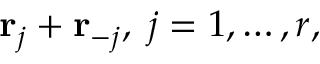Convert formula to latex. <formula><loc_0><loc_0><loc_500><loc_500>{ r } _ { j } + { r } _ { - j } , \, j = 1 , \dots , r ,</formula> 